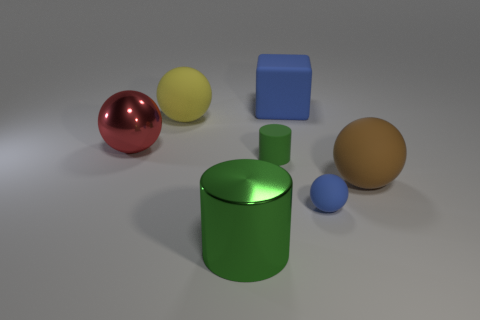Subtract all brown spheres. How many spheres are left? 3 Subtract all brown balls. How many balls are left? 3 Subtract 1 spheres. How many spheres are left? 3 Subtract all green spheres. Subtract all cyan cylinders. How many spheres are left? 4 Add 1 small blue things. How many objects exist? 8 Subtract all cylinders. How many objects are left? 5 Add 7 large blue rubber cubes. How many large blue rubber cubes are left? 8 Add 5 big brown things. How many big brown things exist? 6 Subtract 2 green cylinders. How many objects are left? 5 Subtract all small red metal objects. Subtract all big brown rubber spheres. How many objects are left? 6 